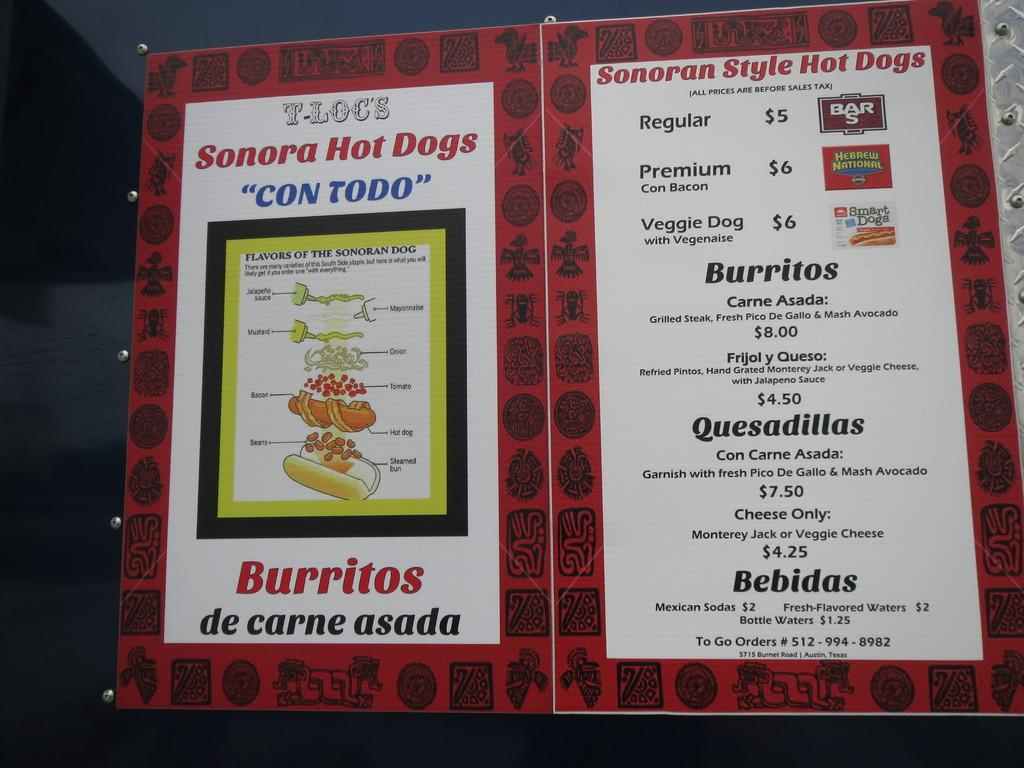<image>
Write a terse but informative summary of the picture. A menu featuring a Sonora Hot Dogs and Burritos. 